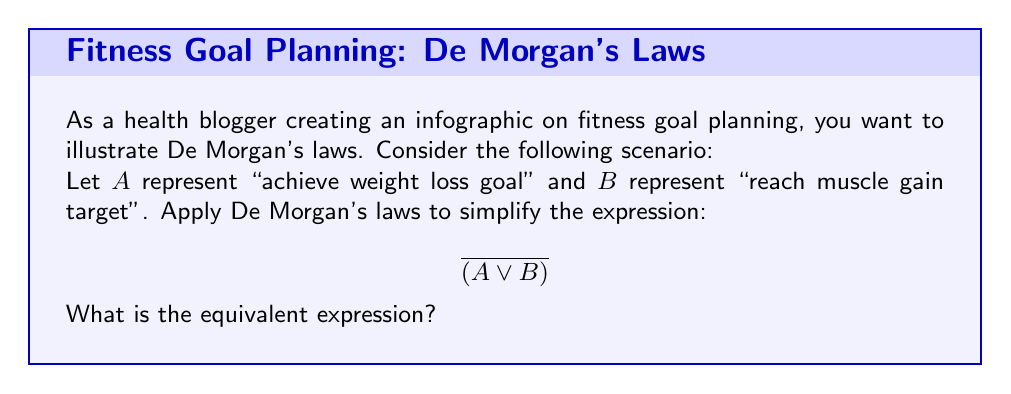Solve this math problem. To solve this problem, we'll apply De Morgan's laws step-by-step:

1. De Morgan's law states that the negation of a disjunction is the conjunction of the negations. In Boolean algebra, this is expressed as:

   $\overline{(X \lor Y)} = \overline{X} \land \overline{Y}$

2. In our case, we have:
   $X = A$ (achieve weight loss goal)
   $Y = B$ (reach muscle gain target)

3. Applying De Morgan's law to our expression:

   $\overline{(A \lor B)} = \overline{A} \land \overline{B}$

4. Interpreting this result in the context of fitness goals:
   - $\overline{A}$ means "not achieve weight loss goal"
   - $\overline{B}$ means "not reach muscle gain target"
   - $\land$ represents "and"

5. Therefore, the simplified expression $\overline{A} \land \overline{B}$ means "not achieve weight loss goal AND not reach muscle gain target"

This result could be used in an infographic to show that failing to achieve either fitness goal is equivalent to not achieving both goals simultaneously.
Answer: $\overline{A} \land \overline{B}$ 